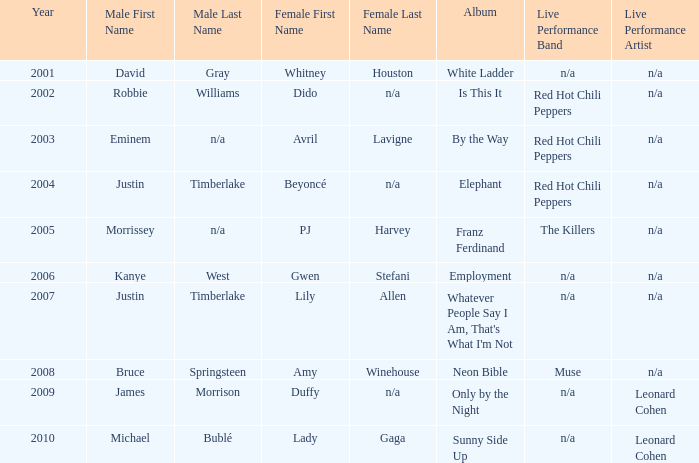Who is the male associate for amy winehouse? Bruce Springsteen. 